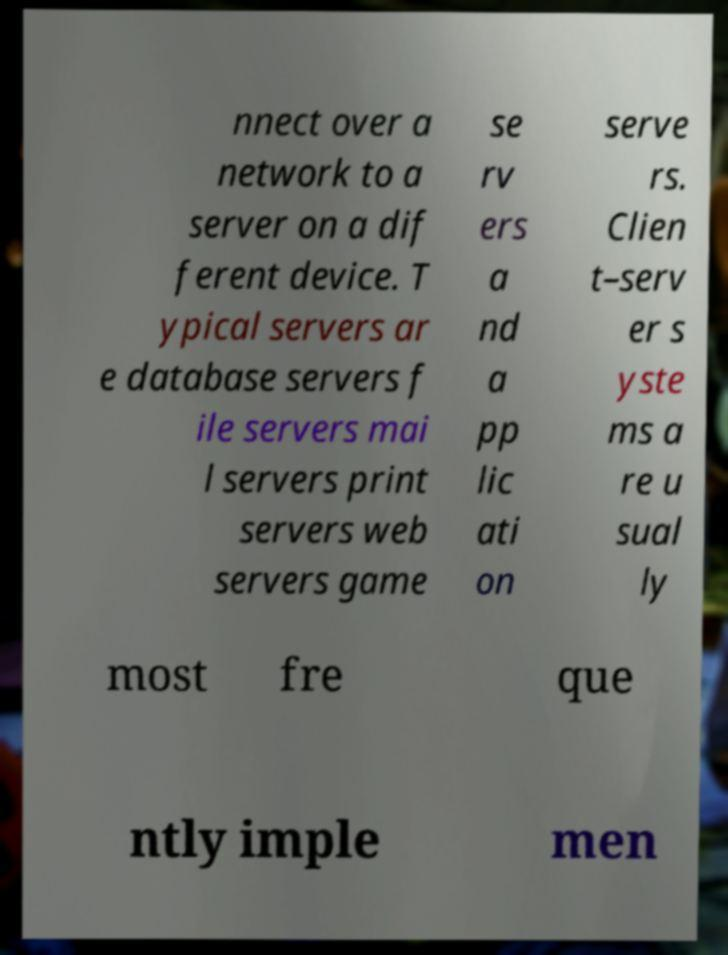What messages or text are displayed in this image? I need them in a readable, typed format. nnect over a network to a server on a dif ferent device. T ypical servers ar e database servers f ile servers mai l servers print servers web servers game se rv ers a nd a pp lic ati on serve rs. Clien t–serv er s yste ms a re u sual ly most fre que ntly imple men 